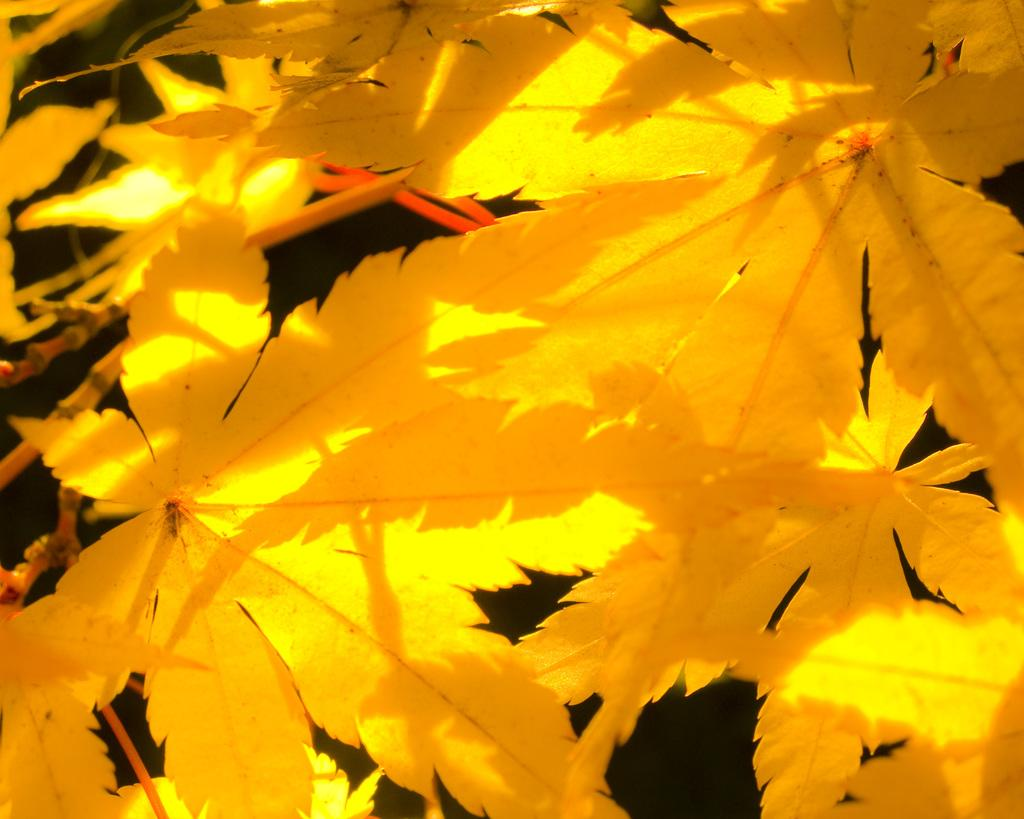What color are the leaves in the image? The leaves in the image are yellow. What can be seen in the background of the image? There is a red object in the background of the image. What is present in the bottom right corner of the image? There is darkness in the bottom right corner of the image. Can you see any airplanes flying over the leaves in the image? There are no airplanes visible in the image. What type of patch is sewn onto the leaves in the image? There are no patches present on the leaves in the image. 